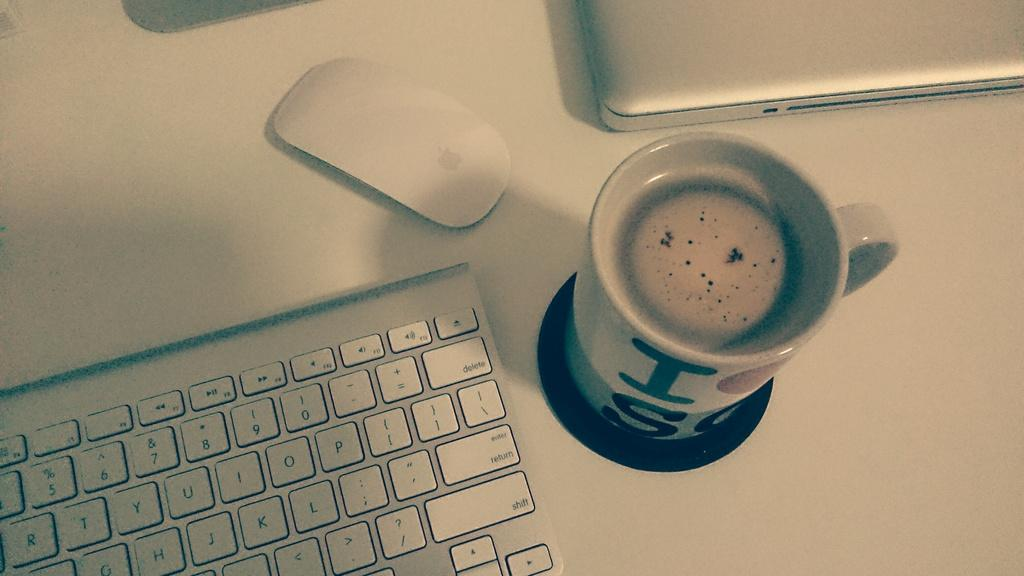What is located in the middle of the image? There is a coffee cup in the middle of the image. What can be seen on the left side of the image? There is a keyboard on the left side of the image. What other object is present in the image? There is a mouse in the image. How many apples are present in the image? There are no apples present in the image. What type of existence does the thing in the image have? The question is unclear and seems to be an attempt to ask about the existence of the objects in the image. However, the objects in the image (coffee cup, keyboard, and mouse) are clearly visible and present. 